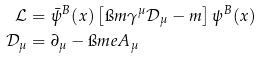Convert formula to latex. <formula><loc_0><loc_0><loc_500><loc_500>\mathcal { L } & = \bar { \psi } ^ { B } ( x ) \left [ \i m \gamma ^ { \mu } \mathcal { D } _ { \mu } - m \right ] \psi ^ { B } ( x ) \\ \mathcal { D } _ { \mu } & = \partial _ { \mu } - \i m e A _ { \mu }</formula> 